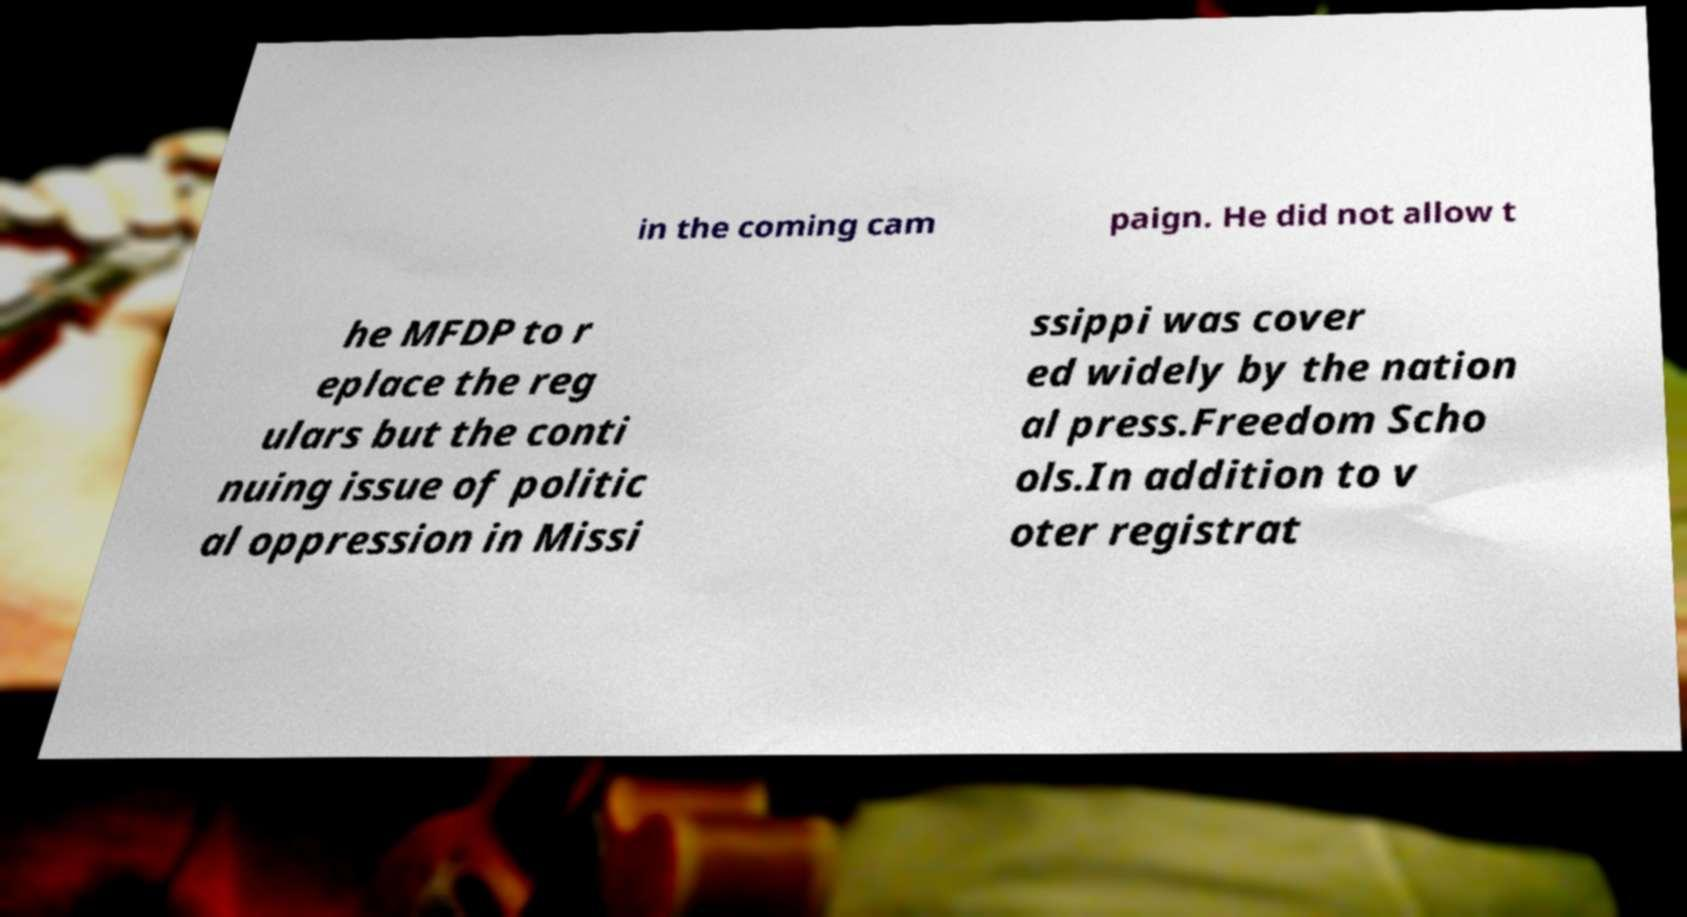Can you read and provide the text displayed in the image?This photo seems to have some interesting text. Can you extract and type it out for me? in the coming cam paign. He did not allow t he MFDP to r eplace the reg ulars but the conti nuing issue of politic al oppression in Missi ssippi was cover ed widely by the nation al press.Freedom Scho ols.In addition to v oter registrat 